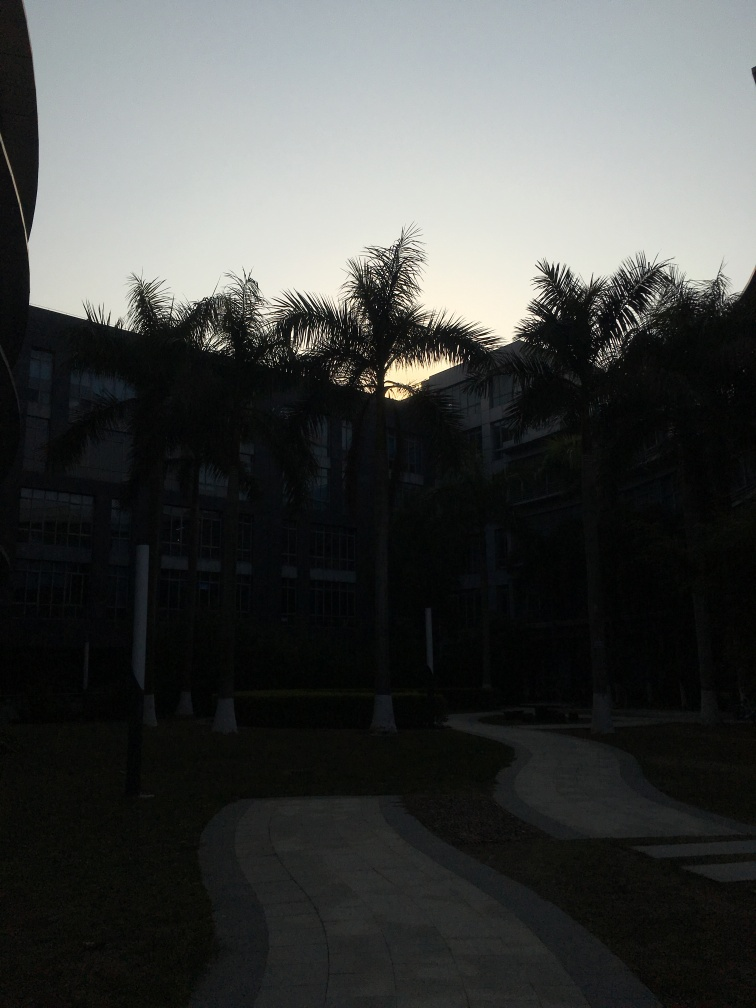Are the background and the house clear?
A. Blurry and barely visible
B. Sharp and easily distinguishable
C. Perfectly in focus
D. Crystal clear and well-defined The background and the house are not as sharp as one would expect for a clear image. The details are difficult to make out due to the low lighting, which seems to be because the photo was taken at either dawn or dusk. Therefore, the objects in the image appear somewhat blurry and not easily distinguishable, fitting option A. 